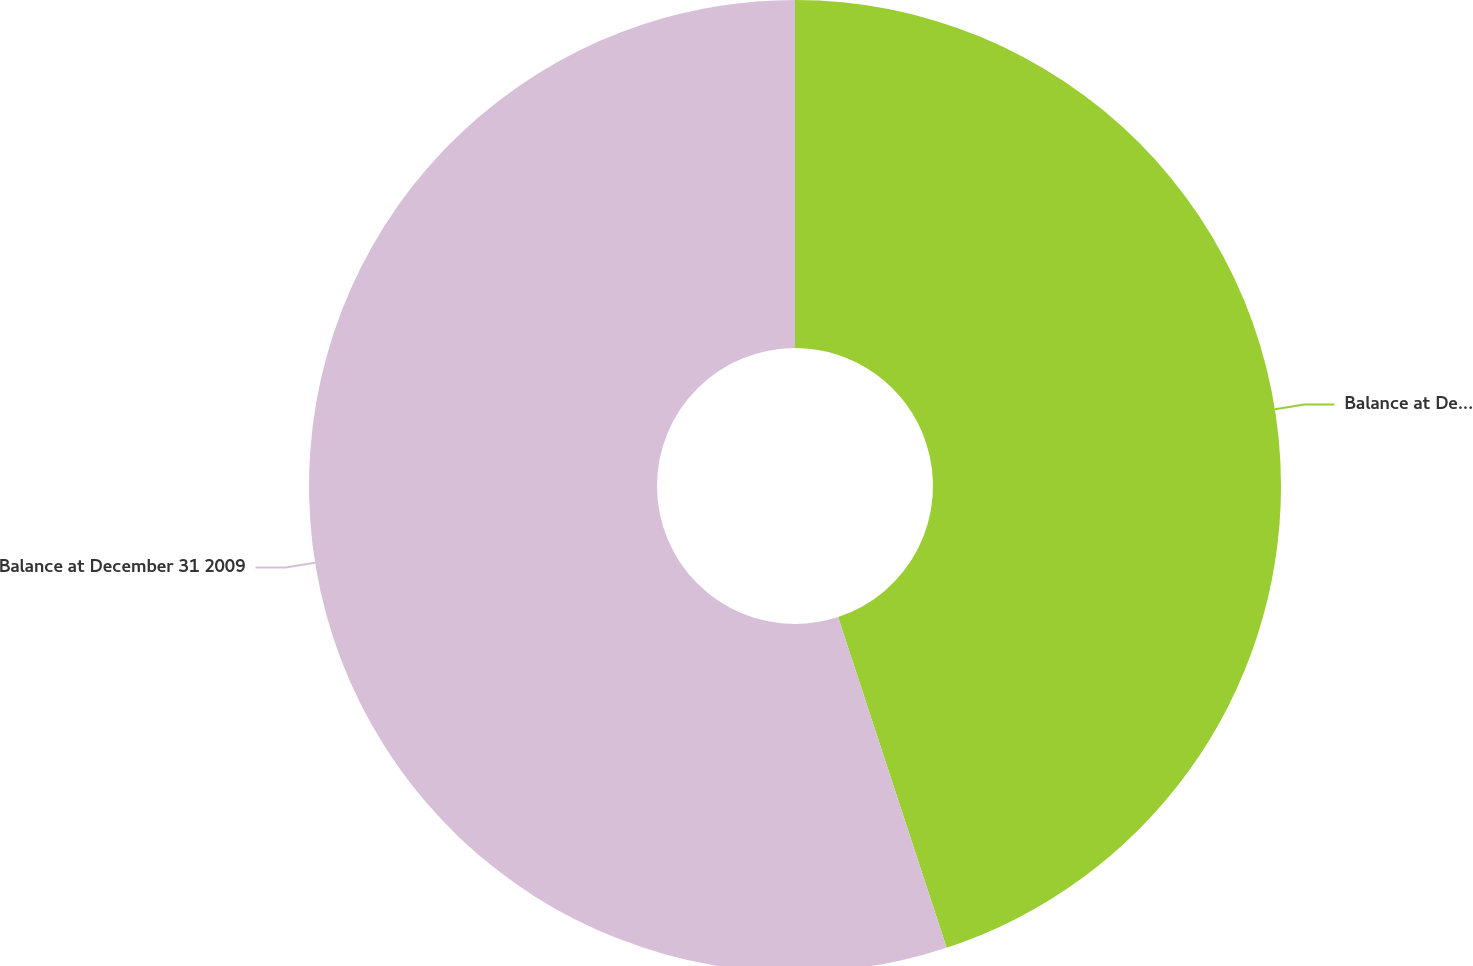Convert chart to OTSL. <chart><loc_0><loc_0><loc_500><loc_500><pie_chart><fcel>Balance at December 31 2007<fcel>Balance at December 31 2009<nl><fcel>44.95%<fcel>55.05%<nl></chart> 